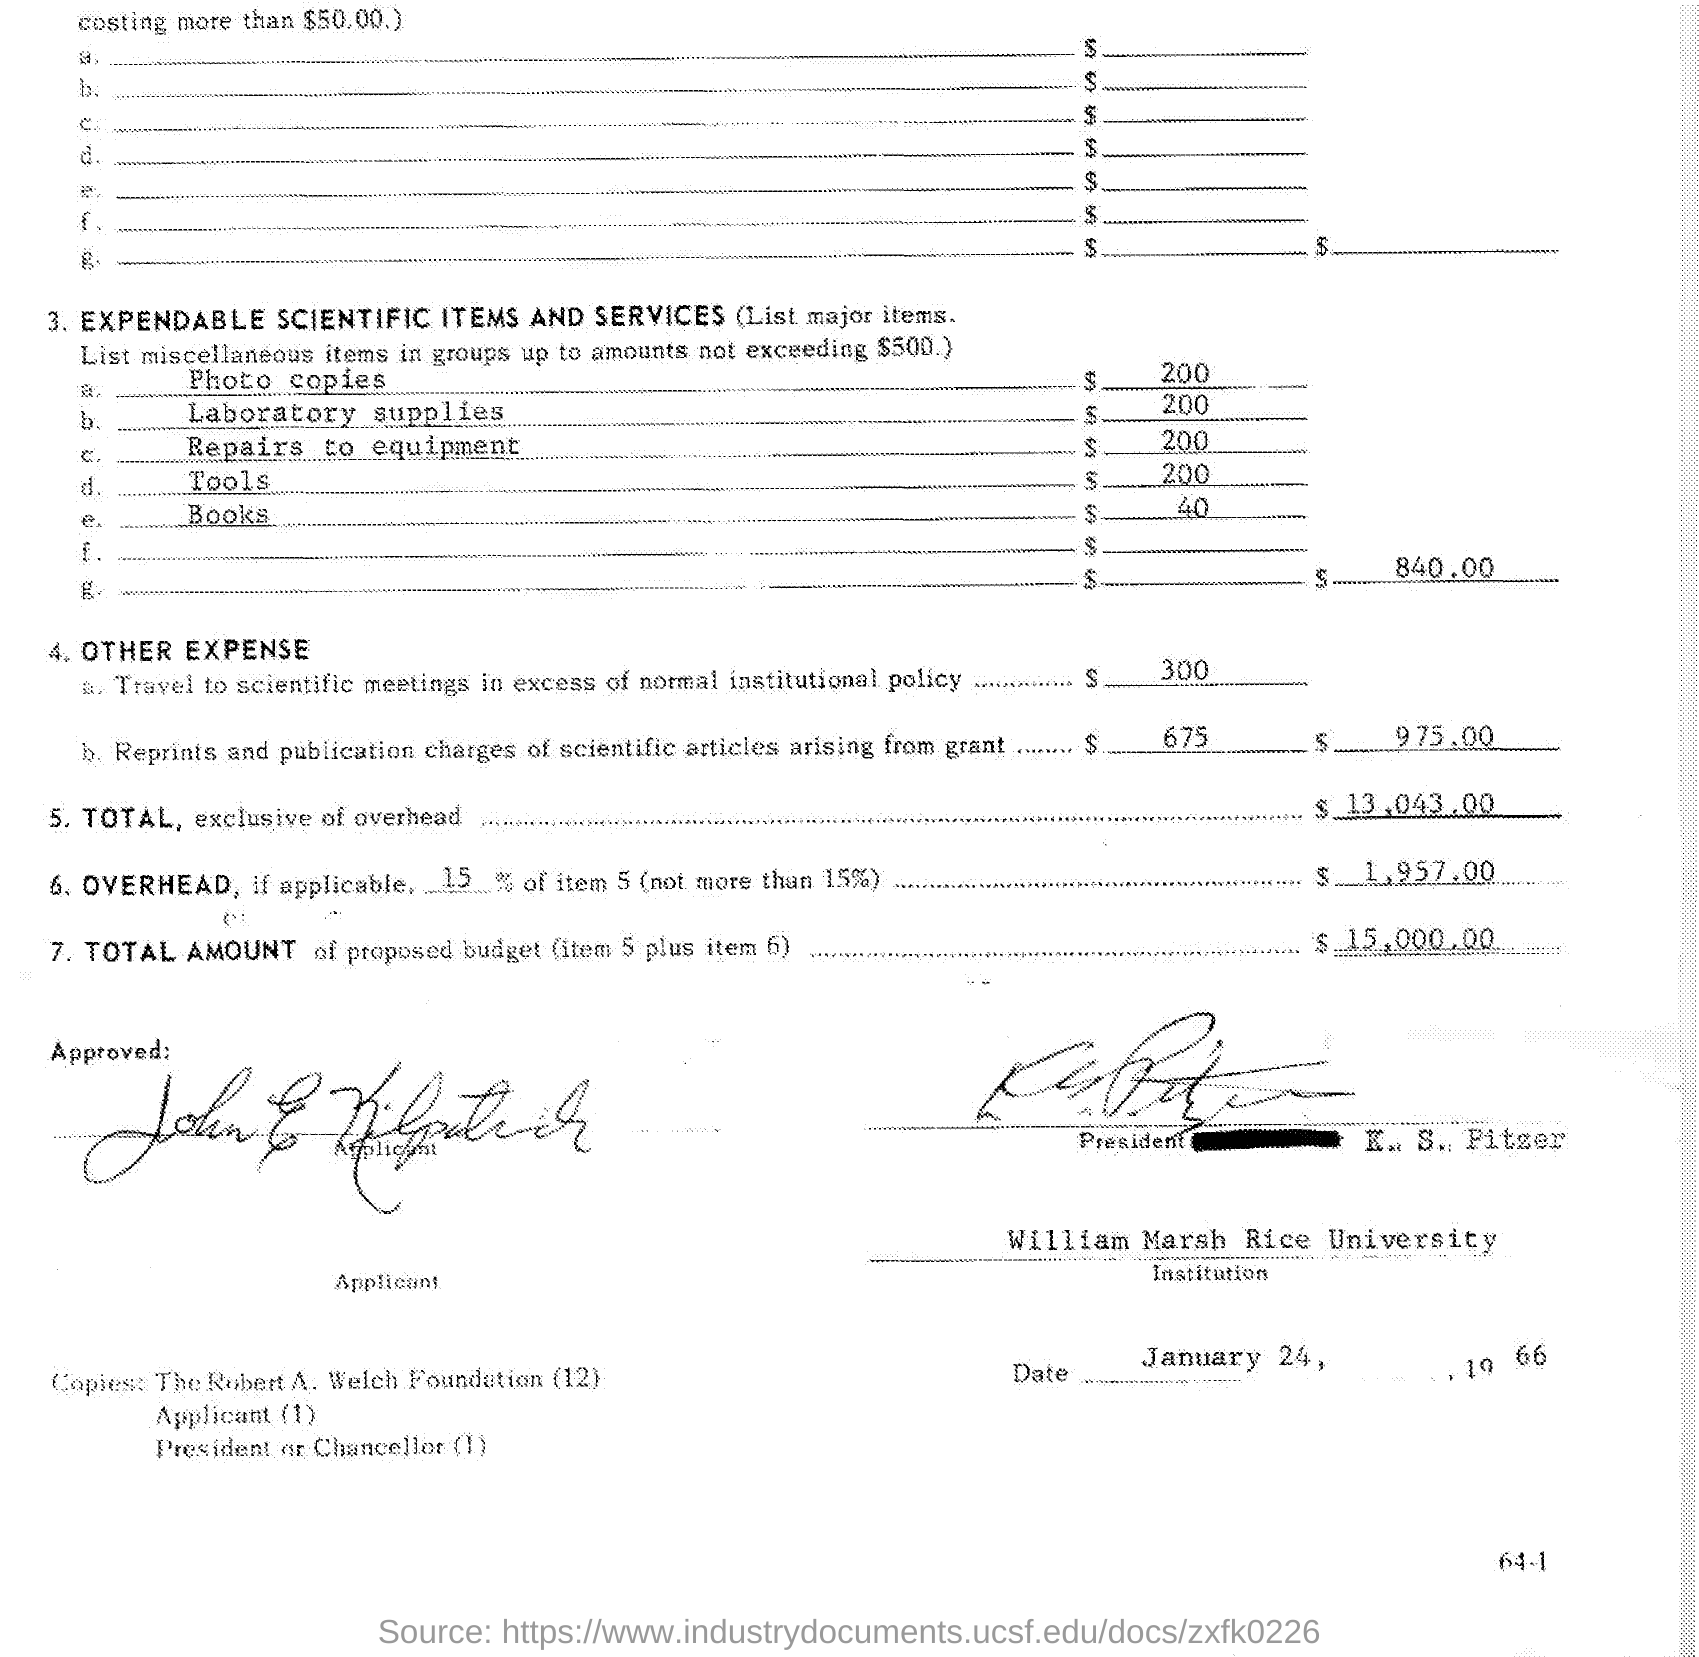How much charged for Repair to equipment?
Keep it short and to the point. $200. Where was 40 dollars charged for?
Make the answer very short. Books. What are the Reprints and Publication Charges of scientific articles arising from grant?
Your response must be concise. $675. 